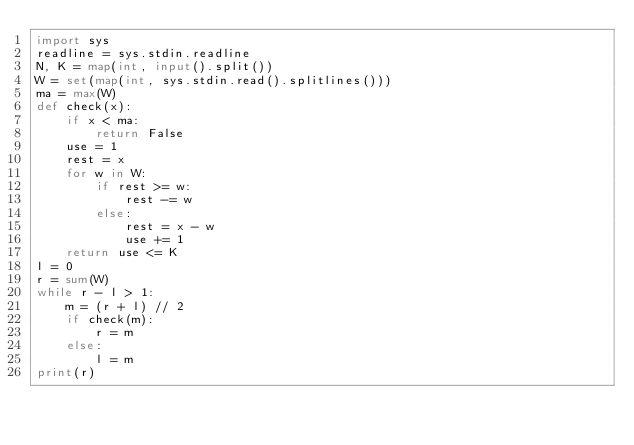<code> <loc_0><loc_0><loc_500><loc_500><_Python_>import sys
readline = sys.stdin.readline
N, K = map(int, input().split())
W = set(map(int, sys.stdin.read().splitlines()))
ma = max(W)
def check(x):
    if x < ma:
        return False
    use = 1
    rest = x
    for w in W:
        if rest >= w:
            rest -= w
        else:
            rest = x - w
            use += 1
    return use <= K
l = 0
r = sum(W)
while r - l > 1:
    m = (r + l) // 2
    if check(m):
        r = m
    else:
        l = m
print(r)
</code> 